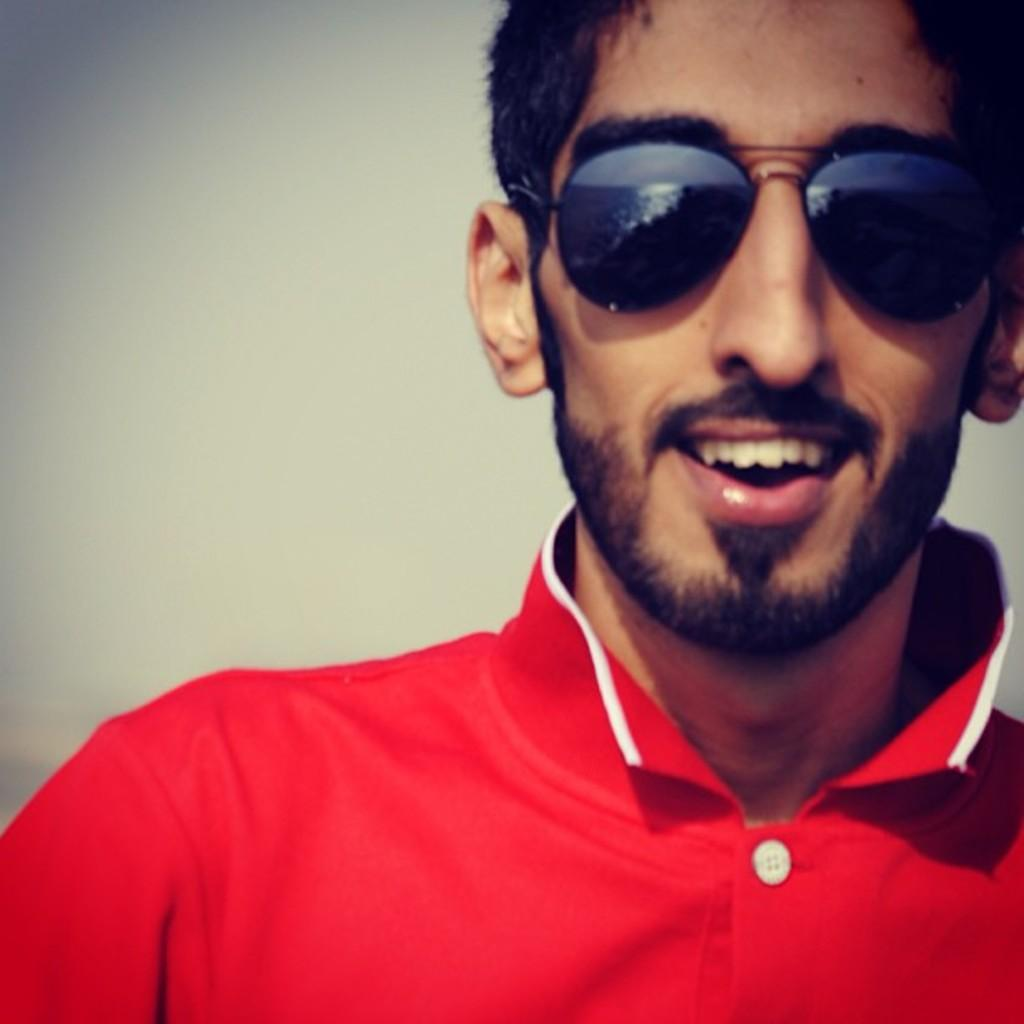Who is present in the image? There is a man in the image. What is the man wearing on his face? The man is wearing black color shades. What color is the dress the man is wearing? The man is wearing a red color dress. How many houses can be seen in the image? There are no houses present in the image; it features a man wearing black shades and a red dress. What type of bottle is the man holding in the image? There is no bottle present in the image. 